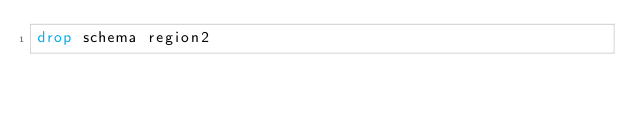<code> <loc_0><loc_0><loc_500><loc_500><_SQL_>drop schema region2
</code> 